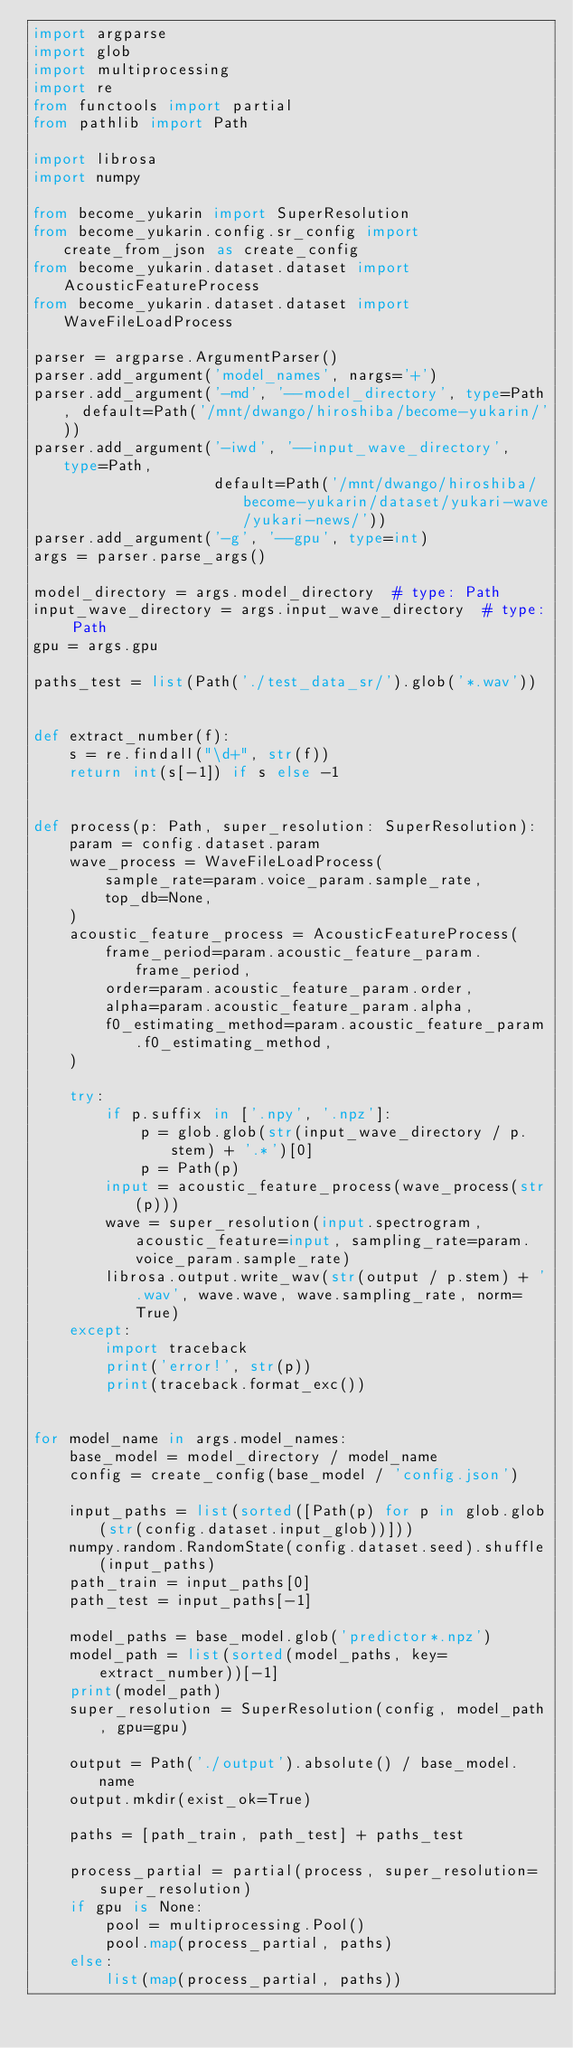<code> <loc_0><loc_0><loc_500><loc_500><_Python_>import argparse
import glob
import multiprocessing
import re
from functools import partial
from pathlib import Path

import librosa
import numpy

from become_yukarin import SuperResolution
from become_yukarin.config.sr_config import create_from_json as create_config
from become_yukarin.dataset.dataset import AcousticFeatureProcess
from become_yukarin.dataset.dataset import WaveFileLoadProcess

parser = argparse.ArgumentParser()
parser.add_argument('model_names', nargs='+')
parser.add_argument('-md', '--model_directory', type=Path, default=Path('/mnt/dwango/hiroshiba/become-yukarin/'))
parser.add_argument('-iwd', '--input_wave_directory', type=Path,
                    default=Path('/mnt/dwango/hiroshiba/become-yukarin/dataset/yukari-wave/yukari-news/'))
parser.add_argument('-g', '--gpu', type=int)
args = parser.parse_args()

model_directory = args.model_directory  # type: Path
input_wave_directory = args.input_wave_directory  # type: Path
gpu = args.gpu

paths_test = list(Path('./test_data_sr/').glob('*.wav'))


def extract_number(f):
    s = re.findall("\d+", str(f))
    return int(s[-1]) if s else -1


def process(p: Path, super_resolution: SuperResolution):
    param = config.dataset.param
    wave_process = WaveFileLoadProcess(
        sample_rate=param.voice_param.sample_rate,
        top_db=None,
    )
    acoustic_feature_process = AcousticFeatureProcess(
        frame_period=param.acoustic_feature_param.frame_period,
        order=param.acoustic_feature_param.order,
        alpha=param.acoustic_feature_param.alpha,
        f0_estimating_method=param.acoustic_feature_param.f0_estimating_method,
    )

    try:
        if p.suffix in ['.npy', '.npz']:
            p = glob.glob(str(input_wave_directory / p.stem) + '.*')[0]
            p = Path(p)
        input = acoustic_feature_process(wave_process(str(p)))
        wave = super_resolution(input.spectrogram, acoustic_feature=input, sampling_rate=param.voice_param.sample_rate)
        librosa.output.write_wav(str(output / p.stem) + '.wav', wave.wave, wave.sampling_rate, norm=True)
    except:
        import traceback
        print('error!', str(p))
        print(traceback.format_exc())


for model_name in args.model_names:
    base_model = model_directory / model_name
    config = create_config(base_model / 'config.json')

    input_paths = list(sorted([Path(p) for p in glob.glob(str(config.dataset.input_glob))]))
    numpy.random.RandomState(config.dataset.seed).shuffle(input_paths)
    path_train = input_paths[0]
    path_test = input_paths[-1]

    model_paths = base_model.glob('predictor*.npz')
    model_path = list(sorted(model_paths, key=extract_number))[-1]
    print(model_path)
    super_resolution = SuperResolution(config, model_path, gpu=gpu)

    output = Path('./output').absolute() / base_model.name
    output.mkdir(exist_ok=True)

    paths = [path_train, path_test] + paths_test

    process_partial = partial(process, super_resolution=super_resolution)
    if gpu is None:
        pool = multiprocessing.Pool()
        pool.map(process_partial, paths)
    else:
        list(map(process_partial, paths))
</code> 